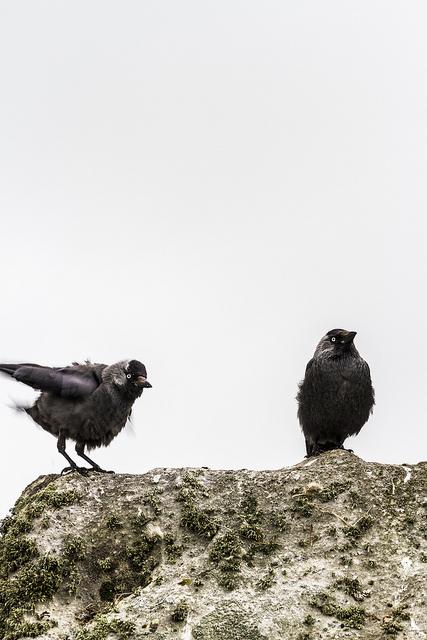Is the bird on the left just landing or about to fly?
Write a very short answer. Landing. Are these birds in the wild?
Keep it brief. Yes. What are the birds standing on?
Short answer required. Rock. What are the birds walking on?
Answer briefly. Rock. 